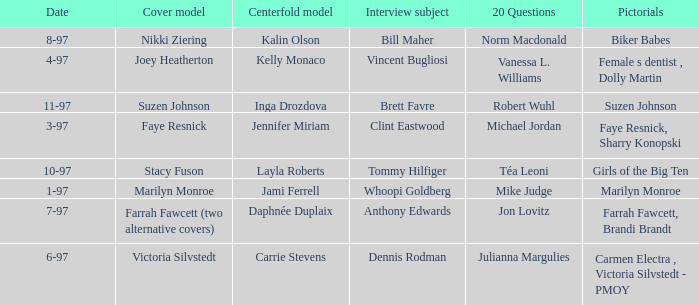When was Kalin Olson listed as  the centerfold model? 8-97. 